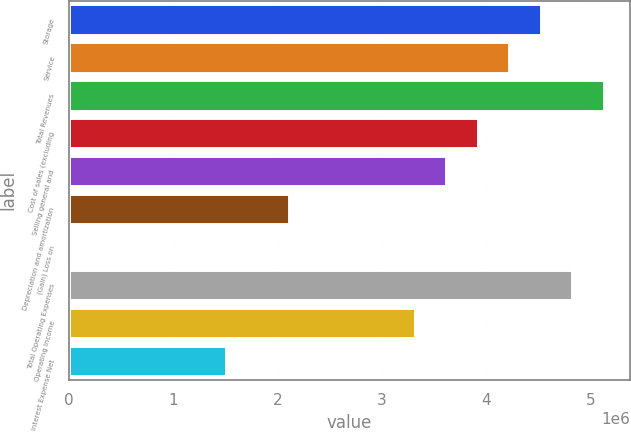Convert chart to OTSL. <chart><loc_0><loc_0><loc_500><loc_500><bar_chart><fcel>Storage<fcel>Service<fcel>Total Revenues<fcel>Cost of sales (excluding<fcel>Selling general and<fcel>Depreciation and amortization<fcel>(Gain) Loss on<fcel>Total Operating Expenses<fcel>Operating Income<fcel>Interest Expense Net<nl><fcel>4.52091e+06<fcel>4.21967e+06<fcel>5.12339e+06<fcel>3.91843e+06<fcel>3.61719e+06<fcel>2.11098e+06<fcel>2286<fcel>4.82215e+06<fcel>3.31594e+06<fcel>1.50849e+06<nl></chart> 